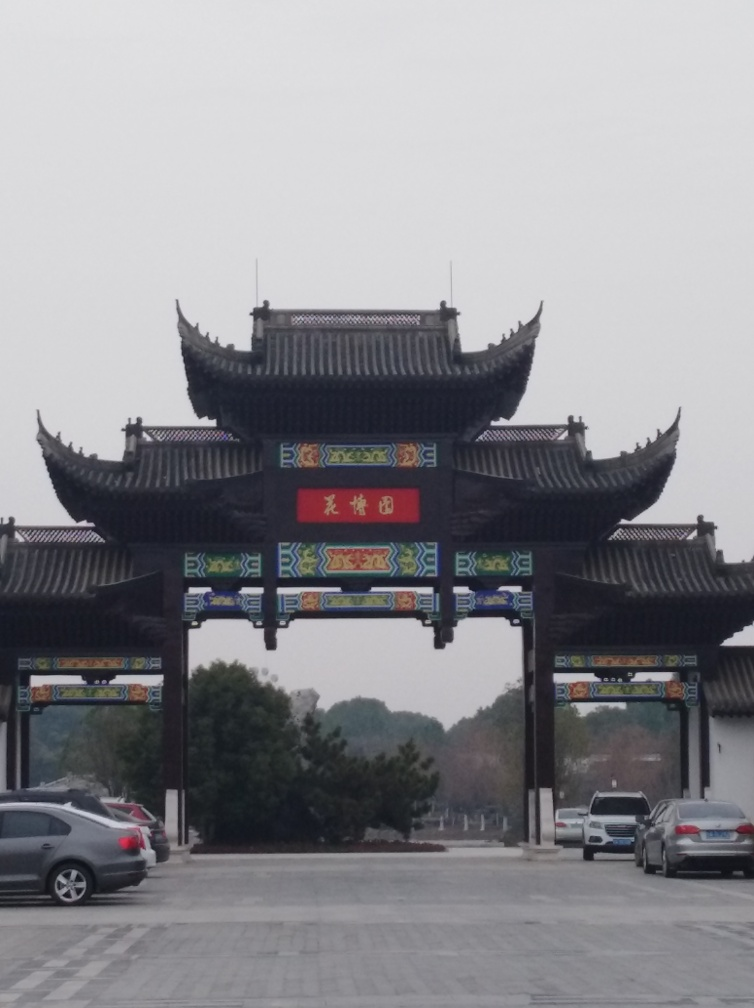Can you tell me more about the architectural style of this building? The architecture in the image is characteristic of traditional Chinese designs, featuring upturned eaves, intricate woodwork, and decorative tiles. These elements are often associated with historical buildings and are prominent in places of cultural importance. 